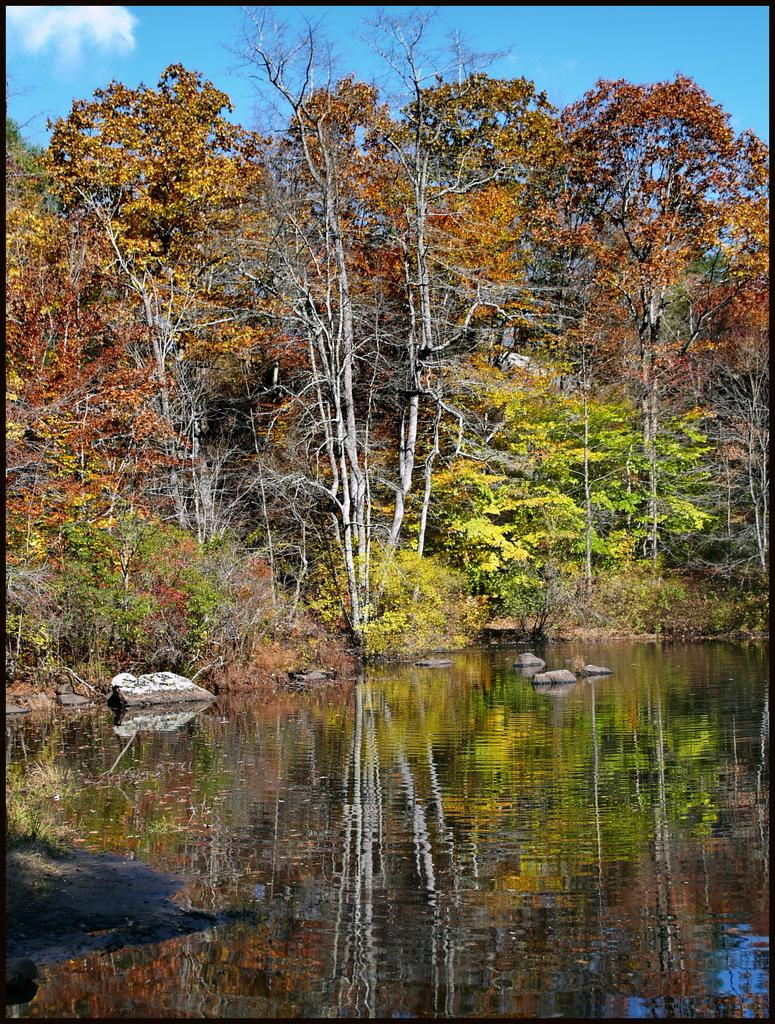What type of vegetation can be seen in the image? There are many trees, plants, and grass in the image. What body of water is present in the image? There is a lake at the bottom of the image. What can be found in the center of the image? There are stones in the center of the image. What is visible at the top of the image? The sky is visible at the top of the image, and there are clouds in the sky. What color is the sweater worn by the person standing next to the tent in the image? There is no person wearing a sweater or tent present in the image; it features natural elements such as trees, plants, grass, a lake, stones, and the sky. 